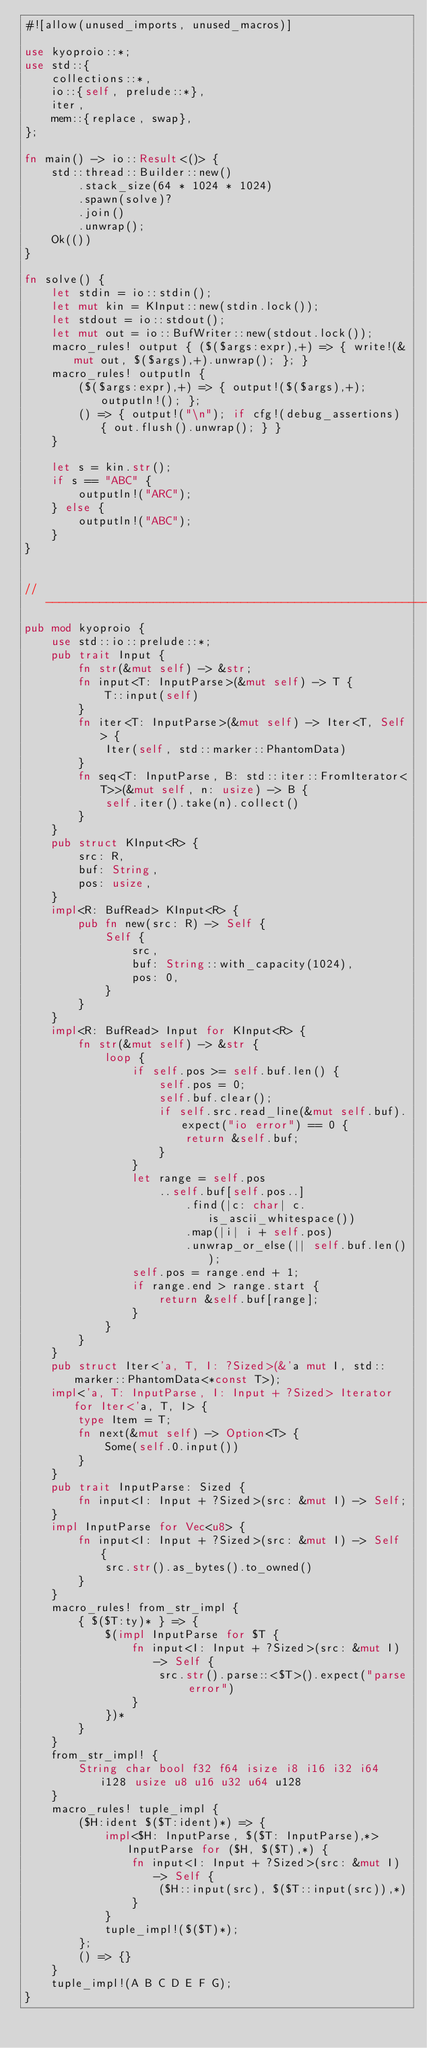<code> <loc_0><loc_0><loc_500><loc_500><_Rust_>#![allow(unused_imports, unused_macros)]

use kyoproio::*;
use std::{
    collections::*,
    io::{self, prelude::*},
    iter,
    mem::{replace, swap},
};

fn main() -> io::Result<()> {
    std::thread::Builder::new()
        .stack_size(64 * 1024 * 1024)
        .spawn(solve)?
        .join()
        .unwrap();
    Ok(())
}

fn solve() {
    let stdin = io::stdin();
    let mut kin = KInput::new(stdin.lock());
    let stdout = io::stdout();
    let mut out = io::BufWriter::new(stdout.lock());
    macro_rules! output { ($($args:expr),+) => { write!(&mut out, $($args),+).unwrap(); }; }
    macro_rules! outputln {
        ($($args:expr),+) => { output!($($args),+); outputln!(); };
        () => { output!("\n"); if cfg!(debug_assertions) { out.flush().unwrap(); } }
    }

    let s = kin.str();
    if s == "ABC" {
        outputln!("ARC");
    } else {
        outputln!("ABC");
    }
}


// -----------------------------------------------------------------------------
pub mod kyoproio {
    use std::io::prelude::*;
    pub trait Input {
        fn str(&mut self) -> &str;
        fn input<T: InputParse>(&mut self) -> T {
            T::input(self)
        }
        fn iter<T: InputParse>(&mut self) -> Iter<T, Self> {
            Iter(self, std::marker::PhantomData)
        }
        fn seq<T: InputParse, B: std::iter::FromIterator<T>>(&mut self, n: usize) -> B {
            self.iter().take(n).collect()
        }
    }
    pub struct KInput<R> {
        src: R,
        buf: String,
        pos: usize,
    }
    impl<R: BufRead> KInput<R> {
        pub fn new(src: R) -> Self {
            Self {
                src,
                buf: String::with_capacity(1024),
                pos: 0,
            }
        }
    }
    impl<R: BufRead> Input for KInput<R> {
        fn str(&mut self) -> &str {
            loop {
                if self.pos >= self.buf.len() {
                    self.pos = 0;
                    self.buf.clear();
                    if self.src.read_line(&mut self.buf).expect("io error") == 0 {
                        return &self.buf;
                    }
                }
                let range = self.pos
                    ..self.buf[self.pos..]
                        .find(|c: char| c.is_ascii_whitespace())
                        .map(|i| i + self.pos)
                        .unwrap_or_else(|| self.buf.len());
                self.pos = range.end + 1;
                if range.end > range.start {
                    return &self.buf[range];
                }
            }
        }
    }
    pub struct Iter<'a, T, I: ?Sized>(&'a mut I, std::marker::PhantomData<*const T>);
    impl<'a, T: InputParse, I: Input + ?Sized> Iterator for Iter<'a, T, I> {
        type Item = T;
        fn next(&mut self) -> Option<T> {
            Some(self.0.input())
        }
    }
    pub trait InputParse: Sized {
        fn input<I: Input + ?Sized>(src: &mut I) -> Self;
    }
    impl InputParse for Vec<u8> {
        fn input<I: Input + ?Sized>(src: &mut I) -> Self {
            src.str().as_bytes().to_owned()
        }
    }
    macro_rules! from_str_impl {
        { $($T:ty)* } => {
            $(impl InputParse for $T {
                fn input<I: Input + ?Sized>(src: &mut I) -> Self {
                    src.str().parse::<$T>().expect("parse error")
                }
            })*
        }
    }
    from_str_impl! {
        String char bool f32 f64 isize i8 i16 i32 i64 i128 usize u8 u16 u32 u64 u128
    }
    macro_rules! tuple_impl {
        ($H:ident $($T:ident)*) => {
            impl<$H: InputParse, $($T: InputParse),*> InputParse for ($H, $($T),*) {
                fn input<I: Input + ?Sized>(src: &mut I) -> Self {
                    ($H::input(src), $($T::input(src)),*)
                }
            }
            tuple_impl!($($T)*);
        };
        () => {}
    }
    tuple_impl!(A B C D E F G);
}
</code> 